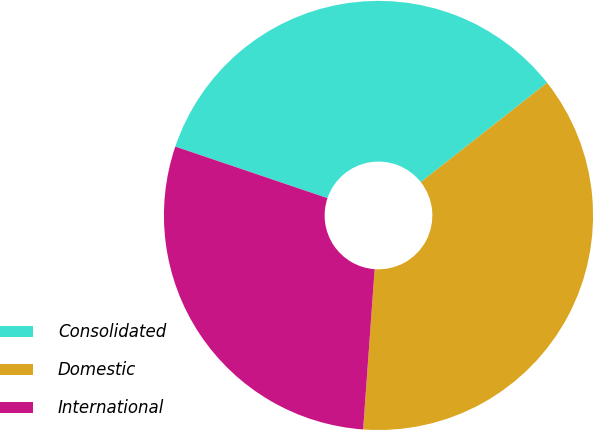Convert chart. <chart><loc_0><loc_0><loc_500><loc_500><pie_chart><fcel>Consolidated<fcel>Domestic<fcel>International<nl><fcel>34.19%<fcel>36.75%<fcel>29.06%<nl></chart> 